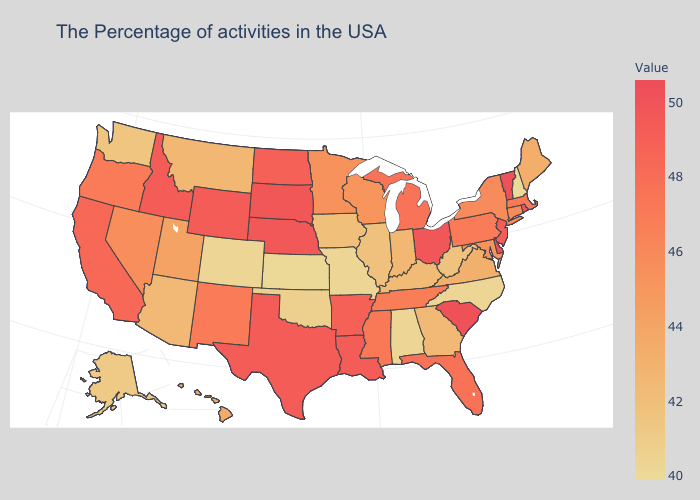Does Arizona have a higher value than Nevada?
Give a very brief answer. No. Among the states that border New Mexico , which have the highest value?
Quick response, please. Texas. Does New Jersey have the lowest value in the Northeast?
Concise answer only. No. Does the map have missing data?
Quick response, please. No. Is the legend a continuous bar?
Short answer required. Yes. Does Alabama have the lowest value in the South?
Quick response, please. Yes. Does North Carolina have the lowest value in the USA?
Be succinct. No. 